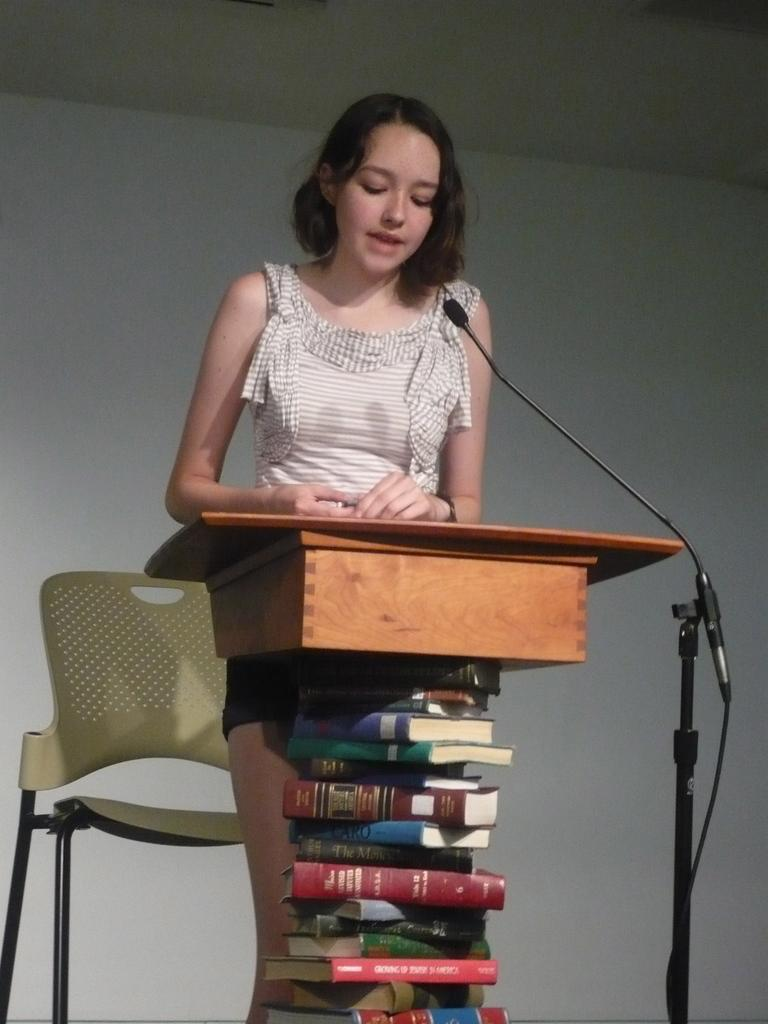What is the appearance of the lady in the image? There is a lady with short hair in the image. What is the lady doing in the image? The lady is standing in the image. What is in front of the lady? There is a desk in front of her. How is the desk supported? The desk is supported by books. What can be seen on the desk? There is a microphone (mike) in the image. What is behind the lady? There is a chair behind the lady. How does the lady contribute to reducing pollution in the image? There is no information about pollution or the lady's actions to reduce it in the image. What type of bulb is used to illuminate the microphone in the image? There is no bulb present in the image; only a microphone is mentioned. 